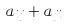<formula> <loc_0><loc_0><loc_500><loc_500>a _ { i j } + a _ { j i }</formula> 